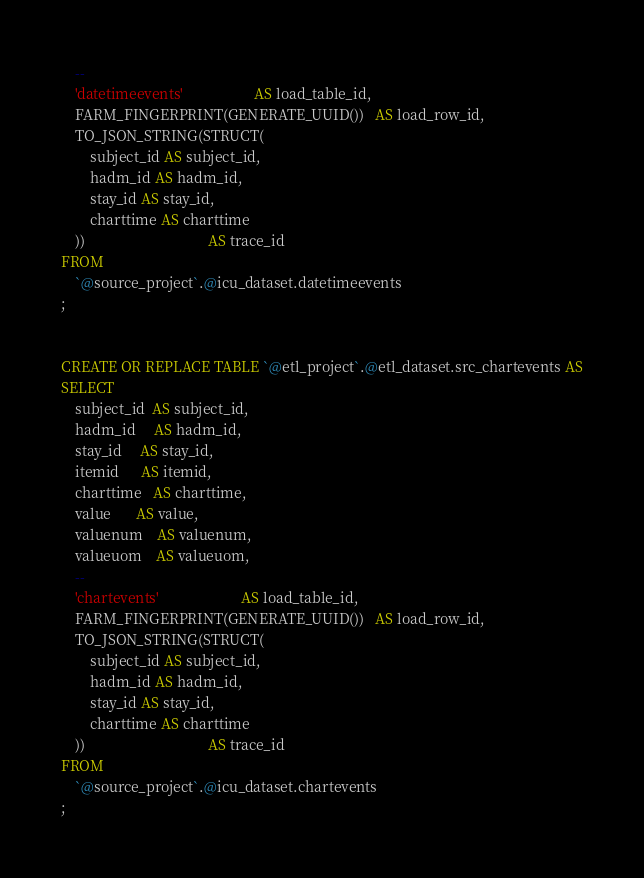<code> <loc_0><loc_0><loc_500><loc_500><_SQL_>    --
    'datetimeevents'                    AS load_table_id,
    FARM_FINGERPRINT(GENERATE_UUID())   AS load_row_id,
    TO_JSON_STRING(STRUCT(
        subject_id AS subject_id,
        hadm_id AS hadm_id,
        stay_id AS stay_id,
        charttime AS charttime
    ))                                  AS trace_id
FROM
    `@source_project`.@icu_dataset.datetimeevents
;


CREATE OR REPLACE TABLE `@etl_project`.@etl_dataset.src_chartevents AS
SELECT
    subject_id  AS subject_id,
    hadm_id     AS hadm_id,
    stay_id     AS stay_id,
    itemid      AS itemid,
    charttime   AS charttime,
    value       AS value,
    valuenum    AS valuenum,
    valueuom    AS valueuom,
    --
    'chartevents'                       AS load_table_id,
    FARM_FINGERPRINT(GENERATE_UUID())   AS load_row_id,
    TO_JSON_STRING(STRUCT(
        subject_id AS subject_id,
        hadm_id AS hadm_id,
        stay_id AS stay_id,
        charttime AS charttime
    ))                                  AS trace_id
FROM
    `@source_project`.@icu_dataset.chartevents
;
</code> 